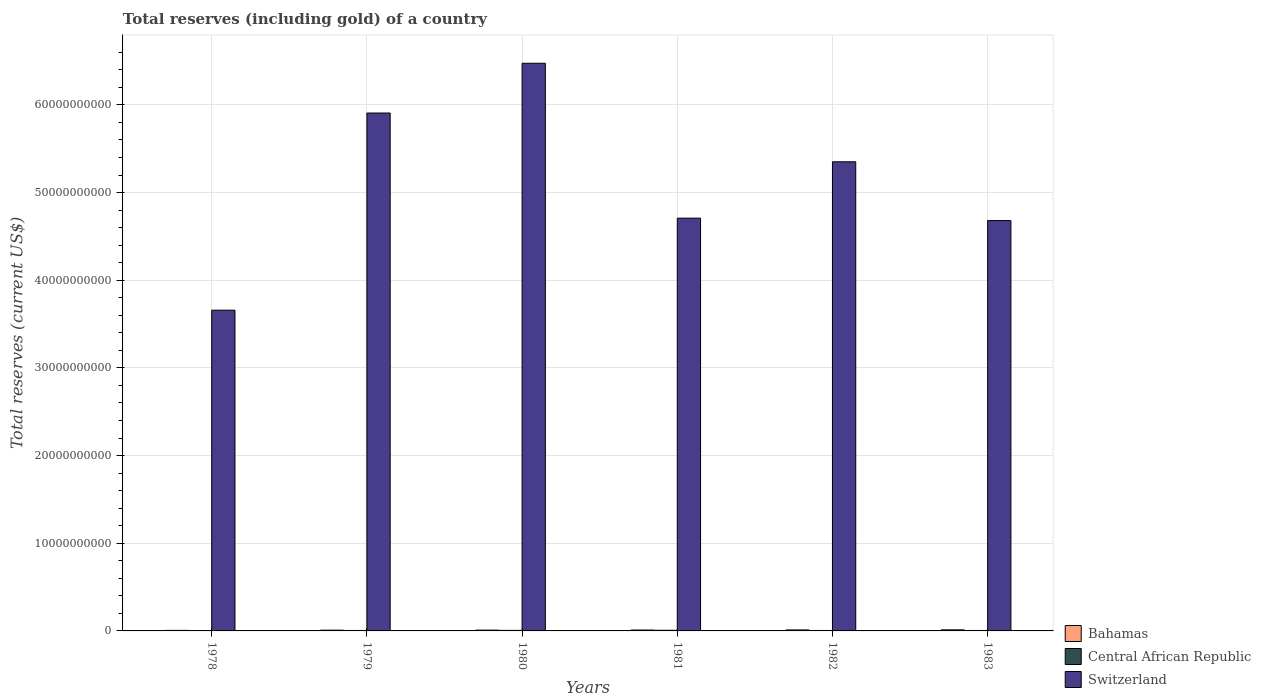How many groups of bars are there?
Your answer should be compact. 6. Are the number of bars per tick equal to the number of legend labels?
Give a very brief answer. Yes. Are the number of bars on each tick of the X-axis equal?
Offer a very short reply. Yes. How many bars are there on the 5th tick from the right?
Offer a very short reply. 3. What is the label of the 5th group of bars from the left?
Offer a terse response. 1982. What is the total reserves (including gold) in Central African Republic in 1981?
Your answer should be very brief. 7.38e+07. Across all years, what is the maximum total reserves (including gold) in Central African Republic?
Give a very brief answer. 7.38e+07. Across all years, what is the minimum total reserves (including gold) in Switzerland?
Keep it short and to the point. 3.66e+1. In which year was the total reserves (including gold) in Bahamas maximum?
Give a very brief answer. 1983. In which year was the total reserves (including gold) in Switzerland minimum?
Provide a succinct answer. 1978. What is the total total reserves (including gold) in Switzerland in the graph?
Your response must be concise. 3.08e+11. What is the difference between the total reserves (including gold) in Central African Republic in 1981 and that in 1982?
Your answer should be very brief. 2.22e+07. What is the difference between the total reserves (including gold) in Central African Republic in 1978 and the total reserves (including gold) in Bahamas in 1979?
Your answer should be compact. -6.02e+07. What is the average total reserves (including gold) in Central African Republic per year?
Make the answer very short. 5.24e+07. In the year 1979, what is the difference between the total reserves (including gold) in Central African Republic and total reserves (including gold) in Switzerland?
Offer a terse response. -5.90e+1. What is the ratio of the total reserves (including gold) in Bahamas in 1978 to that in 1981?
Offer a very short reply. 0.61. Is the total reserves (including gold) in Central African Republic in 1978 less than that in 1980?
Offer a terse response. Yes. What is the difference between the highest and the second highest total reserves (including gold) in Switzerland?
Give a very brief answer. 5.68e+09. What is the difference between the highest and the lowest total reserves (including gold) in Central African Republic?
Keep it short and to the point. 4.78e+07. Is the sum of the total reserves (including gold) in Central African Republic in 1980 and 1982 greater than the maximum total reserves (including gold) in Switzerland across all years?
Ensure brevity in your answer.  No. What does the 2nd bar from the left in 1982 represents?
Offer a very short reply. Central African Republic. What does the 1st bar from the right in 1981 represents?
Make the answer very short. Switzerland. Are all the bars in the graph horizontal?
Offer a very short reply. No. How many years are there in the graph?
Make the answer very short. 6. Are the values on the major ticks of Y-axis written in scientific E-notation?
Give a very brief answer. No. Does the graph contain any zero values?
Make the answer very short. No. Does the graph contain grids?
Provide a short and direct response. Yes. How many legend labels are there?
Keep it short and to the point. 3. How are the legend labels stacked?
Your response must be concise. Vertical. What is the title of the graph?
Give a very brief answer. Total reserves (including gold) of a country. What is the label or title of the X-axis?
Your answer should be compact. Years. What is the label or title of the Y-axis?
Provide a succinct answer. Total reserves (current US$). What is the Total reserves (current US$) of Bahamas in 1978?
Give a very brief answer. 6.10e+07. What is the Total reserves (current US$) in Central African Republic in 1978?
Provide a short and direct response. 2.61e+07. What is the Total reserves (current US$) in Switzerland in 1978?
Your answer should be very brief. 3.66e+1. What is the Total reserves (current US$) in Bahamas in 1979?
Offer a very short reply. 8.63e+07. What is the Total reserves (current US$) in Central African Republic in 1979?
Give a very brief answer. 4.99e+07. What is the Total reserves (current US$) of Switzerland in 1979?
Your answer should be compact. 5.91e+1. What is the Total reserves (current US$) in Bahamas in 1980?
Provide a short and direct response. 9.23e+07. What is the Total reserves (current US$) in Central African Republic in 1980?
Your response must be concise. 6.17e+07. What is the Total reserves (current US$) of Switzerland in 1980?
Make the answer very short. 6.47e+1. What is the Total reserves (current US$) in Bahamas in 1981?
Keep it short and to the point. 1.00e+08. What is the Total reserves (current US$) in Central African Republic in 1981?
Provide a succinct answer. 7.38e+07. What is the Total reserves (current US$) of Switzerland in 1981?
Your answer should be compact. 4.71e+1. What is the Total reserves (current US$) of Bahamas in 1982?
Make the answer very short. 1.13e+08. What is the Total reserves (current US$) of Central African Republic in 1982?
Your answer should be very brief. 5.16e+07. What is the Total reserves (current US$) in Switzerland in 1982?
Ensure brevity in your answer.  5.35e+1. What is the Total reserves (current US$) in Bahamas in 1983?
Give a very brief answer. 1.22e+08. What is the Total reserves (current US$) in Central African Republic in 1983?
Offer a terse response. 5.11e+07. What is the Total reserves (current US$) of Switzerland in 1983?
Offer a very short reply. 4.68e+1. Across all years, what is the maximum Total reserves (current US$) of Bahamas?
Your answer should be compact. 1.22e+08. Across all years, what is the maximum Total reserves (current US$) in Central African Republic?
Make the answer very short. 7.38e+07. Across all years, what is the maximum Total reserves (current US$) in Switzerland?
Provide a short and direct response. 6.47e+1. Across all years, what is the minimum Total reserves (current US$) of Bahamas?
Provide a succinct answer. 6.10e+07. Across all years, what is the minimum Total reserves (current US$) of Central African Republic?
Your answer should be compact. 2.61e+07. Across all years, what is the minimum Total reserves (current US$) of Switzerland?
Your response must be concise. 3.66e+1. What is the total Total reserves (current US$) in Bahamas in the graph?
Your answer should be compact. 5.75e+08. What is the total Total reserves (current US$) in Central African Republic in the graph?
Your response must be concise. 3.14e+08. What is the total Total reserves (current US$) of Switzerland in the graph?
Keep it short and to the point. 3.08e+11. What is the difference between the Total reserves (current US$) in Bahamas in 1978 and that in 1979?
Give a very brief answer. -2.53e+07. What is the difference between the Total reserves (current US$) of Central African Republic in 1978 and that in 1979?
Your answer should be very brief. -2.39e+07. What is the difference between the Total reserves (current US$) in Switzerland in 1978 and that in 1979?
Give a very brief answer. -2.25e+1. What is the difference between the Total reserves (current US$) in Bahamas in 1978 and that in 1980?
Keep it short and to the point. -3.13e+07. What is the difference between the Total reserves (current US$) of Central African Republic in 1978 and that in 1980?
Your response must be concise. -3.56e+07. What is the difference between the Total reserves (current US$) of Switzerland in 1978 and that in 1980?
Keep it short and to the point. -2.82e+1. What is the difference between the Total reserves (current US$) of Bahamas in 1978 and that in 1981?
Make the answer very short. -3.92e+07. What is the difference between the Total reserves (current US$) of Central African Republic in 1978 and that in 1981?
Provide a short and direct response. -4.78e+07. What is the difference between the Total reserves (current US$) in Switzerland in 1978 and that in 1981?
Your answer should be very brief. -1.05e+1. What is the difference between the Total reserves (current US$) of Bahamas in 1978 and that in 1982?
Your answer should be compact. -5.25e+07. What is the difference between the Total reserves (current US$) in Central African Republic in 1978 and that in 1982?
Offer a terse response. -2.55e+07. What is the difference between the Total reserves (current US$) in Switzerland in 1978 and that in 1982?
Offer a very short reply. -1.69e+1. What is the difference between the Total reserves (current US$) in Bahamas in 1978 and that in 1983?
Your answer should be very brief. -6.10e+07. What is the difference between the Total reserves (current US$) in Central African Republic in 1978 and that in 1983?
Offer a terse response. -2.51e+07. What is the difference between the Total reserves (current US$) of Switzerland in 1978 and that in 1983?
Offer a very short reply. -1.02e+1. What is the difference between the Total reserves (current US$) of Bahamas in 1979 and that in 1980?
Ensure brevity in your answer.  -5.97e+06. What is the difference between the Total reserves (current US$) in Central African Republic in 1979 and that in 1980?
Your response must be concise. -1.18e+07. What is the difference between the Total reserves (current US$) of Switzerland in 1979 and that in 1980?
Your answer should be compact. -5.68e+09. What is the difference between the Total reserves (current US$) of Bahamas in 1979 and that in 1981?
Provide a succinct answer. -1.39e+07. What is the difference between the Total reserves (current US$) in Central African Republic in 1979 and that in 1981?
Your response must be concise. -2.39e+07. What is the difference between the Total reserves (current US$) of Switzerland in 1979 and that in 1981?
Provide a succinct answer. 1.20e+1. What is the difference between the Total reserves (current US$) of Bahamas in 1979 and that in 1982?
Keep it short and to the point. -2.72e+07. What is the difference between the Total reserves (current US$) in Central African Republic in 1979 and that in 1982?
Make the answer very short. -1.63e+06. What is the difference between the Total reserves (current US$) of Switzerland in 1979 and that in 1982?
Your response must be concise. 5.56e+09. What is the difference between the Total reserves (current US$) in Bahamas in 1979 and that in 1983?
Offer a terse response. -3.57e+07. What is the difference between the Total reserves (current US$) of Central African Republic in 1979 and that in 1983?
Ensure brevity in your answer.  -1.19e+06. What is the difference between the Total reserves (current US$) in Switzerland in 1979 and that in 1983?
Your answer should be compact. 1.23e+1. What is the difference between the Total reserves (current US$) in Bahamas in 1980 and that in 1981?
Your answer should be very brief. -7.94e+06. What is the difference between the Total reserves (current US$) in Central African Republic in 1980 and that in 1981?
Make the answer very short. -1.21e+07. What is the difference between the Total reserves (current US$) of Switzerland in 1980 and that in 1981?
Provide a succinct answer. 1.77e+1. What is the difference between the Total reserves (current US$) in Bahamas in 1980 and that in 1982?
Give a very brief answer. -2.12e+07. What is the difference between the Total reserves (current US$) of Central African Republic in 1980 and that in 1982?
Your answer should be very brief. 1.01e+07. What is the difference between the Total reserves (current US$) of Switzerland in 1980 and that in 1982?
Offer a terse response. 1.12e+1. What is the difference between the Total reserves (current US$) in Bahamas in 1980 and that in 1983?
Provide a succinct answer. -2.97e+07. What is the difference between the Total reserves (current US$) of Central African Republic in 1980 and that in 1983?
Your answer should be very brief. 1.06e+07. What is the difference between the Total reserves (current US$) of Switzerland in 1980 and that in 1983?
Keep it short and to the point. 1.79e+1. What is the difference between the Total reserves (current US$) in Bahamas in 1981 and that in 1982?
Keep it short and to the point. -1.33e+07. What is the difference between the Total reserves (current US$) of Central African Republic in 1981 and that in 1982?
Your answer should be very brief. 2.22e+07. What is the difference between the Total reserves (current US$) in Switzerland in 1981 and that in 1982?
Your response must be concise. -6.43e+09. What is the difference between the Total reserves (current US$) in Bahamas in 1981 and that in 1983?
Your response must be concise. -2.18e+07. What is the difference between the Total reserves (current US$) in Central African Republic in 1981 and that in 1983?
Your answer should be very brief. 2.27e+07. What is the difference between the Total reserves (current US$) in Switzerland in 1981 and that in 1983?
Provide a short and direct response. 2.78e+08. What is the difference between the Total reserves (current US$) of Bahamas in 1982 and that in 1983?
Your answer should be very brief. -8.49e+06. What is the difference between the Total reserves (current US$) of Central African Republic in 1982 and that in 1983?
Keep it short and to the point. 4.38e+05. What is the difference between the Total reserves (current US$) in Switzerland in 1982 and that in 1983?
Your answer should be very brief. 6.71e+09. What is the difference between the Total reserves (current US$) in Bahamas in 1978 and the Total reserves (current US$) in Central African Republic in 1979?
Keep it short and to the point. 1.11e+07. What is the difference between the Total reserves (current US$) in Bahamas in 1978 and the Total reserves (current US$) in Switzerland in 1979?
Your response must be concise. -5.90e+1. What is the difference between the Total reserves (current US$) of Central African Republic in 1978 and the Total reserves (current US$) of Switzerland in 1979?
Your answer should be compact. -5.90e+1. What is the difference between the Total reserves (current US$) in Bahamas in 1978 and the Total reserves (current US$) in Central African Republic in 1980?
Keep it short and to the point. -6.87e+05. What is the difference between the Total reserves (current US$) of Bahamas in 1978 and the Total reserves (current US$) of Switzerland in 1980?
Make the answer very short. -6.47e+1. What is the difference between the Total reserves (current US$) of Central African Republic in 1978 and the Total reserves (current US$) of Switzerland in 1980?
Your answer should be compact. -6.47e+1. What is the difference between the Total reserves (current US$) of Bahamas in 1978 and the Total reserves (current US$) of Central African Republic in 1981?
Your response must be concise. -1.28e+07. What is the difference between the Total reserves (current US$) in Bahamas in 1978 and the Total reserves (current US$) in Switzerland in 1981?
Provide a succinct answer. -4.70e+1. What is the difference between the Total reserves (current US$) of Central African Republic in 1978 and the Total reserves (current US$) of Switzerland in 1981?
Keep it short and to the point. -4.71e+1. What is the difference between the Total reserves (current US$) of Bahamas in 1978 and the Total reserves (current US$) of Central African Republic in 1982?
Offer a very short reply. 9.43e+06. What is the difference between the Total reserves (current US$) of Bahamas in 1978 and the Total reserves (current US$) of Switzerland in 1982?
Your answer should be compact. -5.34e+1. What is the difference between the Total reserves (current US$) of Central African Republic in 1978 and the Total reserves (current US$) of Switzerland in 1982?
Offer a terse response. -5.35e+1. What is the difference between the Total reserves (current US$) in Bahamas in 1978 and the Total reserves (current US$) in Central African Republic in 1983?
Your response must be concise. 9.87e+06. What is the difference between the Total reserves (current US$) in Bahamas in 1978 and the Total reserves (current US$) in Switzerland in 1983?
Ensure brevity in your answer.  -4.67e+1. What is the difference between the Total reserves (current US$) of Central African Republic in 1978 and the Total reserves (current US$) of Switzerland in 1983?
Your response must be concise. -4.68e+1. What is the difference between the Total reserves (current US$) in Bahamas in 1979 and the Total reserves (current US$) in Central African Republic in 1980?
Make the answer very short. 2.46e+07. What is the difference between the Total reserves (current US$) in Bahamas in 1979 and the Total reserves (current US$) in Switzerland in 1980?
Your answer should be compact. -6.47e+1. What is the difference between the Total reserves (current US$) of Central African Republic in 1979 and the Total reserves (current US$) of Switzerland in 1980?
Give a very brief answer. -6.47e+1. What is the difference between the Total reserves (current US$) in Bahamas in 1979 and the Total reserves (current US$) in Central African Republic in 1981?
Your response must be concise. 1.25e+07. What is the difference between the Total reserves (current US$) in Bahamas in 1979 and the Total reserves (current US$) in Switzerland in 1981?
Offer a very short reply. -4.70e+1. What is the difference between the Total reserves (current US$) in Central African Republic in 1979 and the Total reserves (current US$) in Switzerland in 1981?
Provide a short and direct response. -4.70e+1. What is the difference between the Total reserves (current US$) in Bahamas in 1979 and the Total reserves (current US$) in Central African Republic in 1982?
Make the answer very short. 3.47e+07. What is the difference between the Total reserves (current US$) of Bahamas in 1979 and the Total reserves (current US$) of Switzerland in 1982?
Offer a very short reply. -5.34e+1. What is the difference between the Total reserves (current US$) of Central African Republic in 1979 and the Total reserves (current US$) of Switzerland in 1982?
Provide a short and direct response. -5.35e+1. What is the difference between the Total reserves (current US$) in Bahamas in 1979 and the Total reserves (current US$) in Central African Republic in 1983?
Your answer should be very brief. 3.52e+07. What is the difference between the Total reserves (current US$) in Bahamas in 1979 and the Total reserves (current US$) in Switzerland in 1983?
Make the answer very short. -4.67e+1. What is the difference between the Total reserves (current US$) in Central African Republic in 1979 and the Total reserves (current US$) in Switzerland in 1983?
Your answer should be compact. -4.68e+1. What is the difference between the Total reserves (current US$) in Bahamas in 1980 and the Total reserves (current US$) in Central African Republic in 1981?
Give a very brief answer. 1.85e+07. What is the difference between the Total reserves (current US$) in Bahamas in 1980 and the Total reserves (current US$) in Switzerland in 1981?
Your response must be concise. -4.70e+1. What is the difference between the Total reserves (current US$) in Central African Republic in 1980 and the Total reserves (current US$) in Switzerland in 1981?
Ensure brevity in your answer.  -4.70e+1. What is the difference between the Total reserves (current US$) in Bahamas in 1980 and the Total reserves (current US$) in Central African Republic in 1982?
Make the answer very short. 4.07e+07. What is the difference between the Total reserves (current US$) of Bahamas in 1980 and the Total reserves (current US$) of Switzerland in 1982?
Your answer should be very brief. -5.34e+1. What is the difference between the Total reserves (current US$) in Central African Republic in 1980 and the Total reserves (current US$) in Switzerland in 1982?
Your answer should be compact. -5.34e+1. What is the difference between the Total reserves (current US$) of Bahamas in 1980 and the Total reserves (current US$) of Central African Republic in 1983?
Your answer should be very brief. 4.11e+07. What is the difference between the Total reserves (current US$) of Bahamas in 1980 and the Total reserves (current US$) of Switzerland in 1983?
Your answer should be compact. -4.67e+1. What is the difference between the Total reserves (current US$) of Central African Republic in 1980 and the Total reserves (current US$) of Switzerland in 1983?
Give a very brief answer. -4.67e+1. What is the difference between the Total reserves (current US$) of Bahamas in 1981 and the Total reserves (current US$) of Central African Republic in 1982?
Make the answer very short. 4.86e+07. What is the difference between the Total reserves (current US$) of Bahamas in 1981 and the Total reserves (current US$) of Switzerland in 1982?
Your answer should be very brief. -5.34e+1. What is the difference between the Total reserves (current US$) in Central African Republic in 1981 and the Total reserves (current US$) in Switzerland in 1982?
Make the answer very short. -5.34e+1. What is the difference between the Total reserves (current US$) of Bahamas in 1981 and the Total reserves (current US$) of Central African Republic in 1983?
Keep it short and to the point. 4.91e+07. What is the difference between the Total reserves (current US$) in Bahamas in 1981 and the Total reserves (current US$) in Switzerland in 1983?
Provide a short and direct response. -4.67e+1. What is the difference between the Total reserves (current US$) in Central African Republic in 1981 and the Total reserves (current US$) in Switzerland in 1983?
Keep it short and to the point. -4.67e+1. What is the difference between the Total reserves (current US$) in Bahamas in 1982 and the Total reserves (current US$) in Central African Republic in 1983?
Ensure brevity in your answer.  6.23e+07. What is the difference between the Total reserves (current US$) of Bahamas in 1982 and the Total reserves (current US$) of Switzerland in 1983?
Your response must be concise. -4.67e+1. What is the difference between the Total reserves (current US$) of Central African Republic in 1982 and the Total reserves (current US$) of Switzerland in 1983?
Give a very brief answer. -4.68e+1. What is the average Total reserves (current US$) of Bahamas per year?
Provide a short and direct response. 9.59e+07. What is the average Total reserves (current US$) in Central African Republic per year?
Your answer should be compact. 5.24e+07. What is the average Total reserves (current US$) in Switzerland per year?
Keep it short and to the point. 5.13e+1. In the year 1978, what is the difference between the Total reserves (current US$) in Bahamas and Total reserves (current US$) in Central African Republic?
Your answer should be compact. 3.50e+07. In the year 1978, what is the difference between the Total reserves (current US$) in Bahamas and Total reserves (current US$) in Switzerland?
Ensure brevity in your answer.  -3.65e+1. In the year 1978, what is the difference between the Total reserves (current US$) of Central African Republic and Total reserves (current US$) of Switzerland?
Provide a short and direct response. -3.66e+1. In the year 1979, what is the difference between the Total reserves (current US$) of Bahamas and Total reserves (current US$) of Central African Republic?
Offer a very short reply. 3.64e+07. In the year 1979, what is the difference between the Total reserves (current US$) in Bahamas and Total reserves (current US$) in Switzerland?
Provide a short and direct response. -5.90e+1. In the year 1979, what is the difference between the Total reserves (current US$) in Central African Republic and Total reserves (current US$) in Switzerland?
Your answer should be very brief. -5.90e+1. In the year 1980, what is the difference between the Total reserves (current US$) in Bahamas and Total reserves (current US$) in Central African Republic?
Keep it short and to the point. 3.06e+07. In the year 1980, what is the difference between the Total reserves (current US$) of Bahamas and Total reserves (current US$) of Switzerland?
Your answer should be compact. -6.47e+1. In the year 1980, what is the difference between the Total reserves (current US$) of Central African Republic and Total reserves (current US$) of Switzerland?
Give a very brief answer. -6.47e+1. In the year 1981, what is the difference between the Total reserves (current US$) of Bahamas and Total reserves (current US$) of Central African Republic?
Your answer should be compact. 2.64e+07. In the year 1981, what is the difference between the Total reserves (current US$) of Bahamas and Total reserves (current US$) of Switzerland?
Keep it short and to the point. -4.70e+1. In the year 1981, what is the difference between the Total reserves (current US$) in Central African Republic and Total reserves (current US$) in Switzerland?
Your answer should be compact. -4.70e+1. In the year 1982, what is the difference between the Total reserves (current US$) in Bahamas and Total reserves (current US$) in Central African Republic?
Your response must be concise. 6.19e+07. In the year 1982, what is the difference between the Total reserves (current US$) of Bahamas and Total reserves (current US$) of Switzerland?
Offer a very short reply. -5.34e+1. In the year 1982, what is the difference between the Total reserves (current US$) in Central African Republic and Total reserves (current US$) in Switzerland?
Give a very brief answer. -5.35e+1. In the year 1983, what is the difference between the Total reserves (current US$) of Bahamas and Total reserves (current US$) of Central African Republic?
Provide a succinct answer. 7.08e+07. In the year 1983, what is the difference between the Total reserves (current US$) in Bahamas and Total reserves (current US$) in Switzerland?
Provide a succinct answer. -4.67e+1. In the year 1983, what is the difference between the Total reserves (current US$) in Central African Republic and Total reserves (current US$) in Switzerland?
Keep it short and to the point. -4.68e+1. What is the ratio of the Total reserves (current US$) of Bahamas in 1978 to that in 1979?
Offer a terse response. 0.71. What is the ratio of the Total reserves (current US$) of Central African Republic in 1978 to that in 1979?
Offer a very short reply. 0.52. What is the ratio of the Total reserves (current US$) in Switzerland in 1978 to that in 1979?
Keep it short and to the point. 0.62. What is the ratio of the Total reserves (current US$) in Bahamas in 1978 to that in 1980?
Provide a succinct answer. 0.66. What is the ratio of the Total reserves (current US$) in Central African Republic in 1978 to that in 1980?
Offer a terse response. 0.42. What is the ratio of the Total reserves (current US$) of Switzerland in 1978 to that in 1980?
Your answer should be very brief. 0.56. What is the ratio of the Total reserves (current US$) of Bahamas in 1978 to that in 1981?
Make the answer very short. 0.61. What is the ratio of the Total reserves (current US$) in Central African Republic in 1978 to that in 1981?
Ensure brevity in your answer.  0.35. What is the ratio of the Total reserves (current US$) of Switzerland in 1978 to that in 1981?
Provide a succinct answer. 0.78. What is the ratio of the Total reserves (current US$) in Bahamas in 1978 to that in 1982?
Ensure brevity in your answer.  0.54. What is the ratio of the Total reserves (current US$) of Central African Republic in 1978 to that in 1982?
Give a very brief answer. 0.51. What is the ratio of the Total reserves (current US$) in Switzerland in 1978 to that in 1982?
Your response must be concise. 0.68. What is the ratio of the Total reserves (current US$) in Bahamas in 1978 to that in 1983?
Offer a terse response. 0.5. What is the ratio of the Total reserves (current US$) of Central African Republic in 1978 to that in 1983?
Your answer should be compact. 0.51. What is the ratio of the Total reserves (current US$) in Switzerland in 1978 to that in 1983?
Make the answer very short. 0.78. What is the ratio of the Total reserves (current US$) in Bahamas in 1979 to that in 1980?
Make the answer very short. 0.94. What is the ratio of the Total reserves (current US$) in Central African Republic in 1979 to that in 1980?
Provide a succinct answer. 0.81. What is the ratio of the Total reserves (current US$) in Switzerland in 1979 to that in 1980?
Give a very brief answer. 0.91. What is the ratio of the Total reserves (current US$) in Bahamas in 1979 to that in 1981?
Offer a terse response. 0.86. What is the ratio of the Total reserves (current US$) of Central African Republic in 1979 to that in 1981?
Provide a succinct answer. 0.68. What is the ratio of the Total reserves (current US$) in Switzerland in 1979 to that in 1981?
Your answer should be compact. 1.25. What is the ratio of the Total reserves (current US$) of Bahamas in 1979 to that in 1982?
Your answer should be very brief. 0.76. What is the ratio of the Total reserves (current US$) of Central African Republic in 1979 to that in 1982?
Provide a succinct answer. 0.97. What is the ratio of the Total reserves (current US$) in Switzerland in 1979 to that in 1982?
Keep it short and to the point. 1.1. What is the ratio of the Total reserves (current US$) of Bahamas in 1979 to that in 1983?
Your answer should be very brief. 0.71. What is the ratio of the Total reserves (current US$) in Central African Republic in 1979 to that in 1983?
Provide a succinct answer. 0.98. What is the ratio of the Total reserves (current US$) of Switzerland in 1979 to that in 1983?
Offer a terse response. 1.26. What is the ratio of the Total reserves (current US$) of Bahamas in 1980 to that in 1981?
Provide a succinct answer. 0.92. What is the ratio of the Total reserves (current US$) of Central African Republic in 1980 to that in 1981?
Keep it short and to the point. 0.84. What is the ratio of the Total reserves (current US$) of Switzerland in 1980 to that in 1981?
Offer a very short reply. 1.38. What is the ratio of the Total reserves (current US$) of Bahamas in 1980 to that in 1982?
Your answer should be compact. 0.81. What is the ratio of the Total reserves (current US$) of Central African Republic in 1980 to that in 1982?
Offer a very short reply. 1.2. What is the ratio of the Total reserves (current US$) of Switzerland in 1980 to that in 1982?
Offer a terse response. 1.21. What is the ratio of the Total reserves (current US$) of Bahamas in 1980 to that in 1983?
Make the answer very short. 0.76. What is the ratio of the Total reserves (current US$) in Central African Republic in 1980 to that in 1983?
Provide a short and direct response. 1.21. What is the ratio of the Total reserves (current US$) of Switzerland in 1980 to that in 1983?
Make the answer very short. 1.38. What is the ratio of the Total reserves (current US$) in Bahamas in 1981 to that in 1982?
Provide a succinct answer. 0.88. What is the ratio of the Total reserves (current US$) in Central African Republic in 1981 to that in 1982?
Provide a short and direct response. 1.43. What is the ratio of the Total reserves (current US$) in Switzerland in 1981 to that in 1982?
Make the answer very short. 0.88. What is the ratio of the Total reserves (current US$) in Bahamas in 1981 to that in 1983?
Ensure brevity in your answer.  0.82. What is the ratio of the Total reserves (current US$) in Central African Republic in 1981 to that in 1983?
Provide a succinct answer. 1.44. What is the ratio of the Total reserves (current US$) in Switzerland in 1981 to that in 1983?
Keep it short and to the point. 1.01. What is the ratio of the Total reserves (current US$) of Bahamas in 1982 to that in 1983?
Ensure brevity in your answer.  0.93. What is the ratio of the Total reserves (current US$) of Central African Republic in 1982 to that in 1983?
Your answer should be compact. 1.01. What is the ratio of the Total reserves (current US$) in Switzerland in 1982 to that in 1983?
Your answer should be compact. 1.14. What is the difference between the highest and the second highest Total reserves (current US$) in Bahamas?
Give a very brief answer. 8.49e+06. What is the difference between the highest and the second highest Total reserves (current US$) of Central African Republic?
Make the answer very short. 1.21e+07. What is the difference between the highest and the second highest Total reserves (current US$) of Switzerland?
Provide a short and direct response. 5.68e+09. What is the difference between the highest and the lowest Total reserves (current US$) in Bahamas?
Give a very brief answer. 6.10e+07. What is the difference between the highest and the lowest Total reserves (current US$) in Central African Republic?
Provide a short and direct response. 4.78e+07. What is the difference between the highest and the lowest Total reserves (current US$) of Switzerland?
Give a very brief answer. 2.82e+1. 